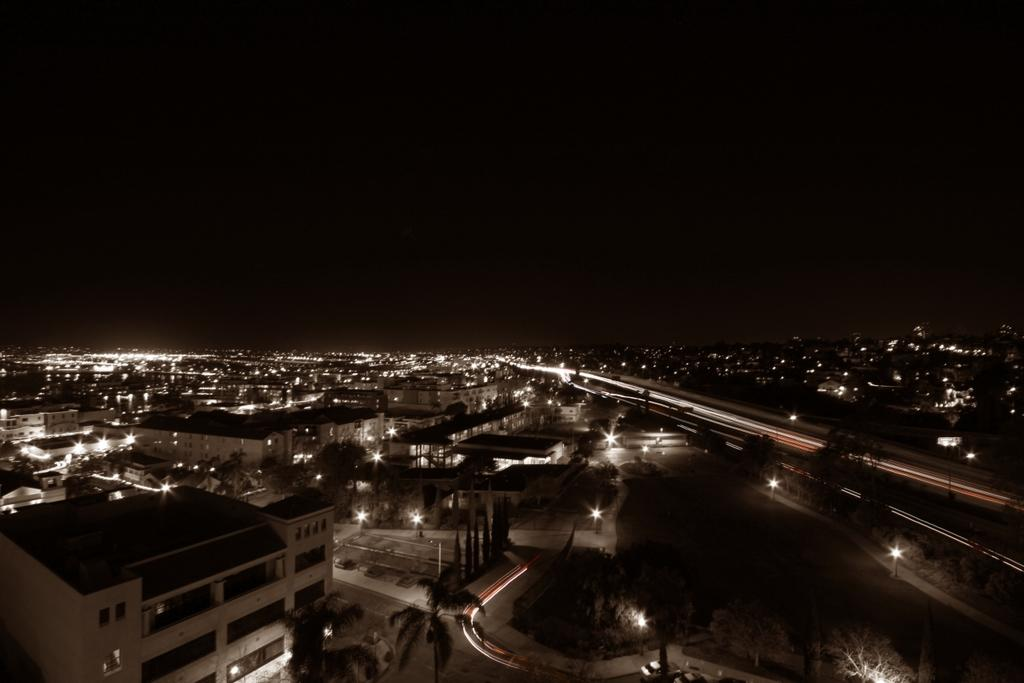What type of structures can be seen in the image? There are buildings in the image. What type of vegetation is present in the image? There are trees in the image. What can be seen illuminating the scene in the image? There are lights visible in the image. What is visible in the background of the image? The sky is visible in the background of the image. What type of condition does the fish have in the image? There is no fish present in the image. How many feet are visible in the image? There are no feet visible in the image. 